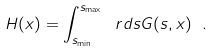<formula> <loc_0><loc_0><loc_500><loc_500>H ( x ) = \int _ { s _ { \min } } ^ { s _ { \max } } \ r d s G ( s , x ) \ .</formula> 